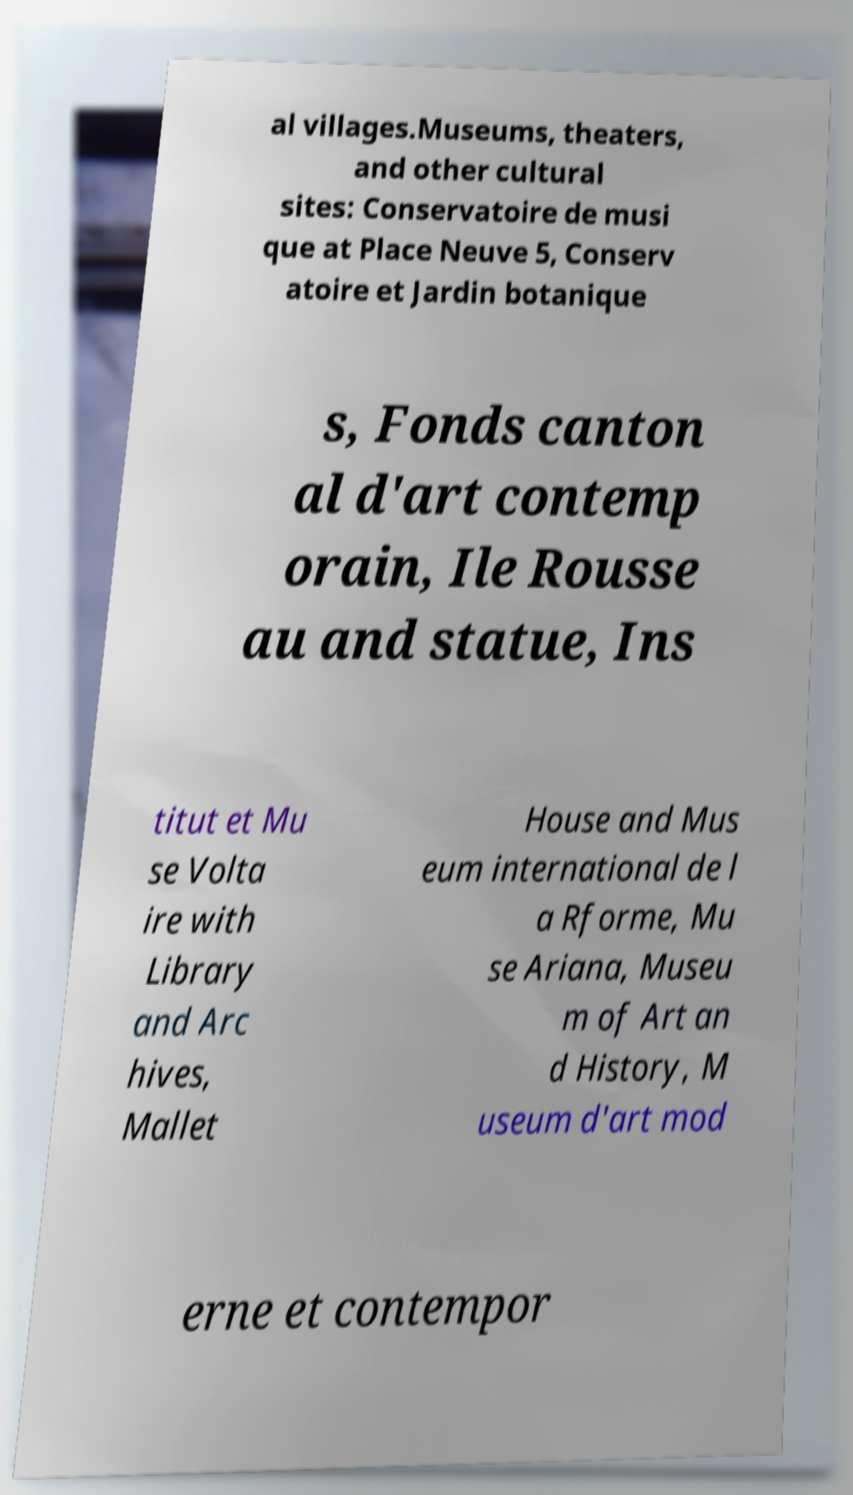Can you accurately transcribe the text from the provided image for me? al villages.Museums, theaters, and other cultural sites: Conservatoire de musi que at Place Neuve 5, Conserv atoire et Jardin botanique s, Fonds canton al d'art contemp orain, Ile Rousse au and statue, Ins titut et Mu se Volta ire with Library and Arc hives, Mallet House and Mus eum international de l a Rforme, Mu se Ariana, Museu m of Art an d History, M useum d'art mod erne et contempor 